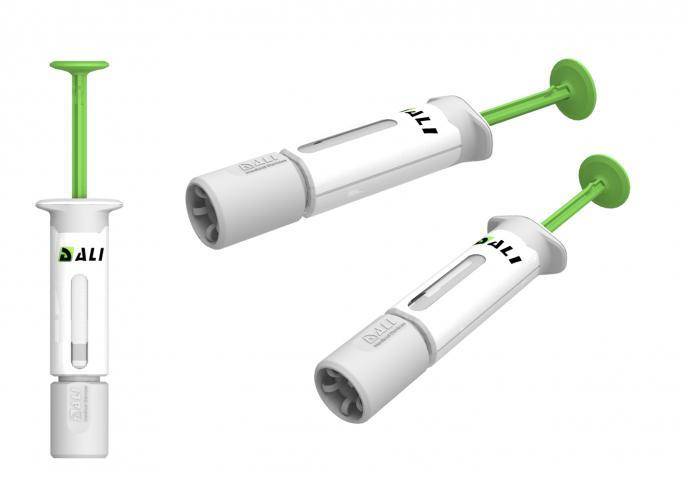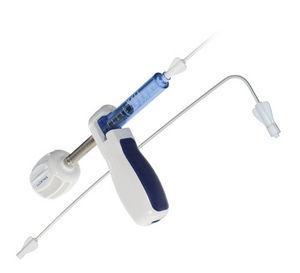The first image is the image on the left, the second image is the image on the right. For the images displayed, is the sentence "3 syringes are pointed to the left." factually correct? Answer yes or no. No. 